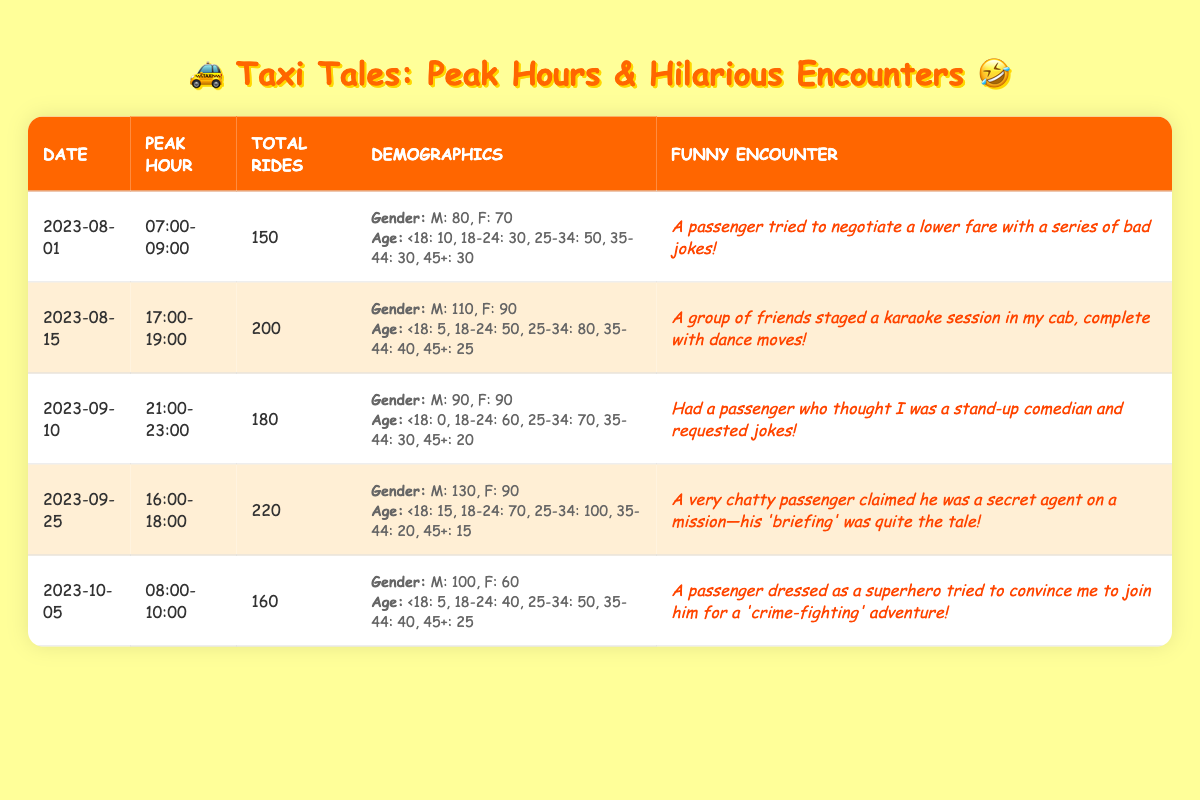What was the total number of rides on September 25, 2023? The table shows that on September 25, 2023, the total number of rides was 220.
Answer: 220 Which gender had more passengers on August 15, 2023? On August 15, 2023, the number of male passengers was 110, while the number of female passengers was 90. Since 110 is greater than 90, males had more passengers that day.
Answer: Male What is the average number of total rides for the dates listed? To find the average, add the total rides for all dates: 150 + 200 + 180 + 220 + 160 = 1110. There are 5 dates, so the average is 1110/5 = 222.
Answer: 222 Did any of the peak hours have a total ride count less than 160? Reviewing the total rides for each date: 150, 200, 180, 220, and 160. The only day with a count less than 160 is August 1, with 150 rides. Therefore, the answer is yes.
Answer: Yes What was the gender distribution of passengers during the 21:00-23:00 peak hour? According to the table, from 21:00-23:00 on September 10, 2023, the gender distribution was 90 male and 90 female riders, which is equal.
Answer: Equal How many rides were there in peak hours that had at least 200 total rides? Reviewing the total rides, we see that on August 15, 2023, there were 200 rides and September 25, 2023, had 220 rides. Thus, there are two instances that meet the criteria.
Answer: 2 On which date did the most rides occur, and how many were there? The date with the highest total rides listed is September 25, 2023, which had 220 total rides.
Answer: September 25, 220 What percentage of total rides on October 5, 2023, were by female passengers? On October 5, 2023, there were 160 total rides, with 60 being female. To find the percentage, divide 60 by 160 and multiply by 100, which gives 37.5%.
Answer: 37.5% Were there more under 18 passengers on August 1 than on October 5? On August 1, there were 10 under 18 passengers, while on October 5, there were only 5. Since 10 is greater than 5, the answer is yes.
Answer: Yes 